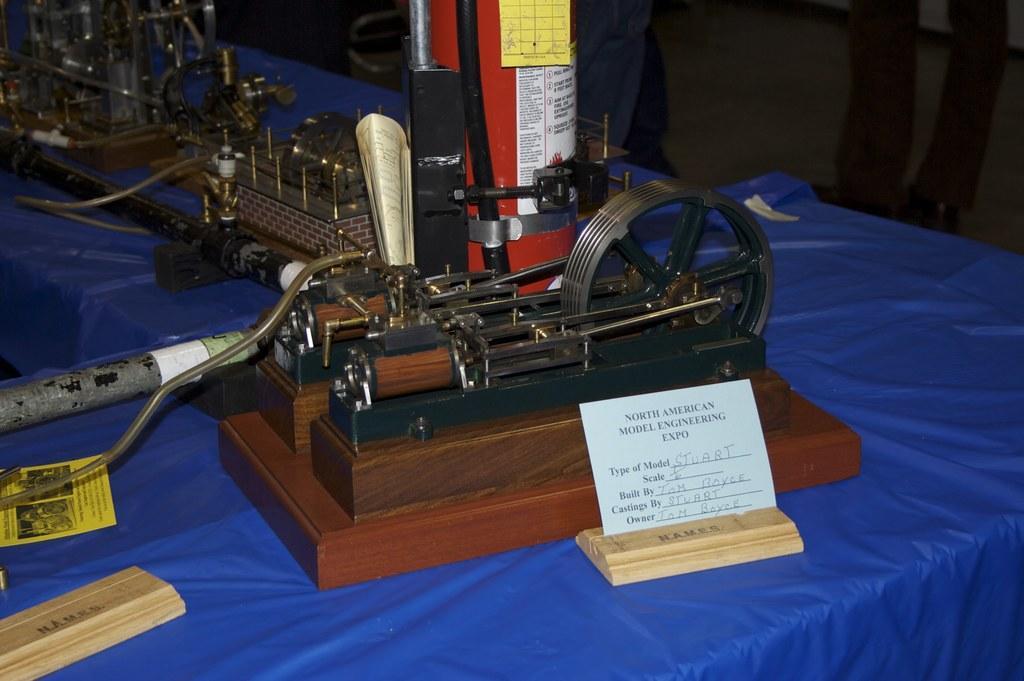Describe this image in one or two sentences. In this image I can see few tables and on it I can see blue colour table cloths, few equipment, few cream colour things, few papers and on these papers I can see something is written. 